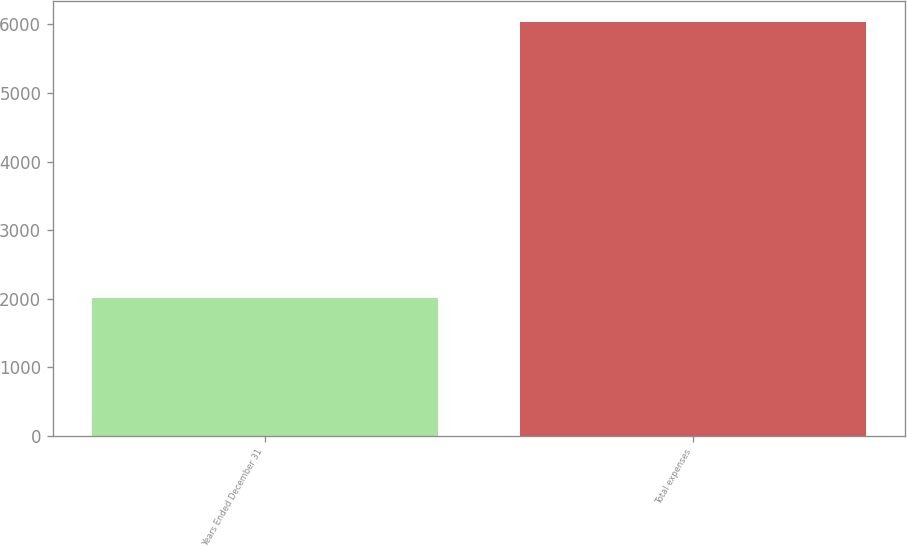<chart> <loc_0><loc_0><loc_500><loc_500><bar_chart><fcel>Years Ended December 31<fcel>Total expenses<nl><fcel>2012<fcel>6041<nl></chart> 